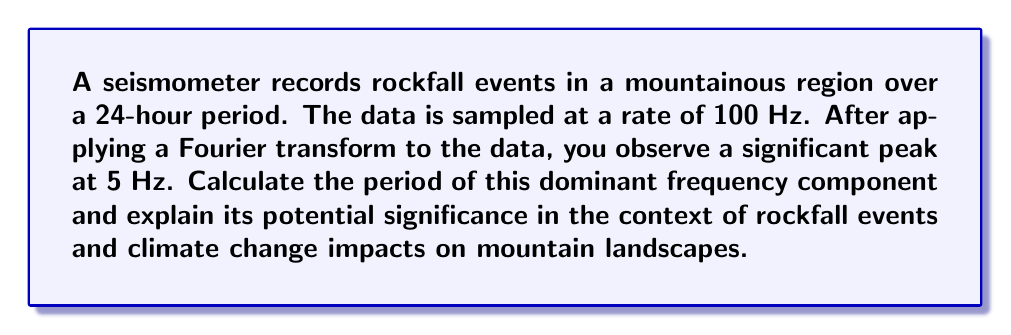Show me your answer to this math problem. To solve this problem, we need to follow these steps:

1) First, recall the relationship between frequency ($f$) and period ($T$):

   $$T = \frac{1}{f}$$

2) We are given that the significant peak is at 5 Hz. Let's substitute this into our equation:

   $$T = \frac{1}{5 \text{ Hz}} = 0.2 \text{ seconds}$$

3) To understand the significance, we need to consider what a 5 Hz frequency might represent in the context of rockfall events:

   a) A 5 Hz frequency corresponds to 5 cycles per second, or a period of 0.2 seconds. This is a relatively high-frequency event in geological terms.
   
   b) In the context of rockfalls, this could represent:
      - The impact frequency of smaller rocks hitting the ground during a rockfall event
      - Vibrations in the mountain caused by the detachment and movement of rocks
      
   c) From a climate change perspective, increased frequency of high-frequency rockfall events could indicate:
      - More frequent freeze-thaw cycles, leading to increased rock fragmentation
      - Increased rainfall leading to more water infiltration and rock destabilization
      - Melting of permafrost, which can destabilize mountain slopes

4) It's important to note that while this frequency is dominant, a full analysis would involve examining the entire frequency spectrum to understand the complete characteristics of rockfall events.

5) For mountain-related injuries, understanding the frequency characteristics of rockfalls can help in:
   - Developing better early warning systems
   - Designing protective equipment and structures
   - Planning safer routes for climbers and hikers
Answer: The period of the dominant frequency component is 0.2 seconds. This high-frequency component could indicate increased rockfall activity due to climate change impacts such as more frequent freeze-thaw cycles, increased rainfall, or permafrost melting, all of which can destabilize mountain landscapes. 